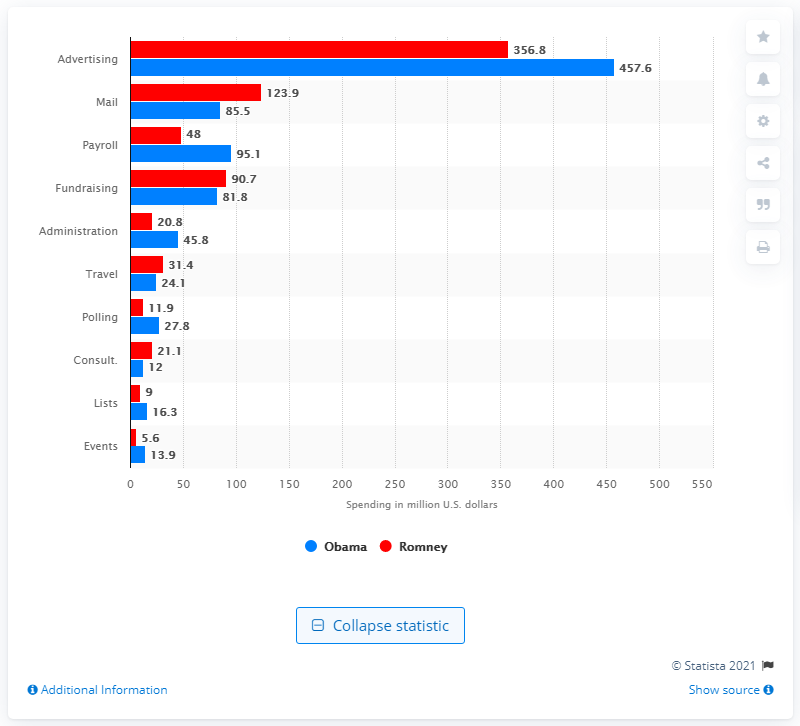List a handful of essential elements in this visual. In October 2012, President Obama spent $457.6 million on ads. 